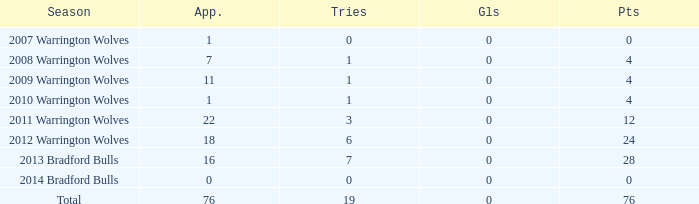How many times is tries 0 and appearance less than 0? 0.0. 